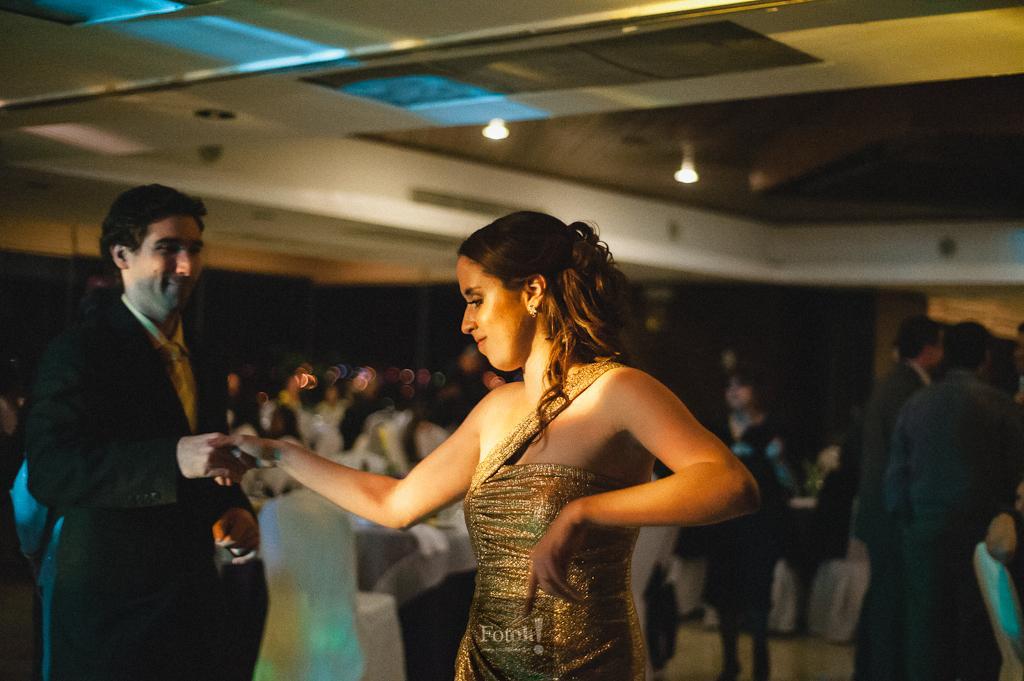Can you describe this image briefly? In the image there are two people a man and a woman, the man is holding the hand of a women and it looks like some party and the background of these two people is blur. 